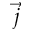Convert formula to latex. <formula><loc_0><loc_0><loc_500><loc_500>\vec { j }</formula> 